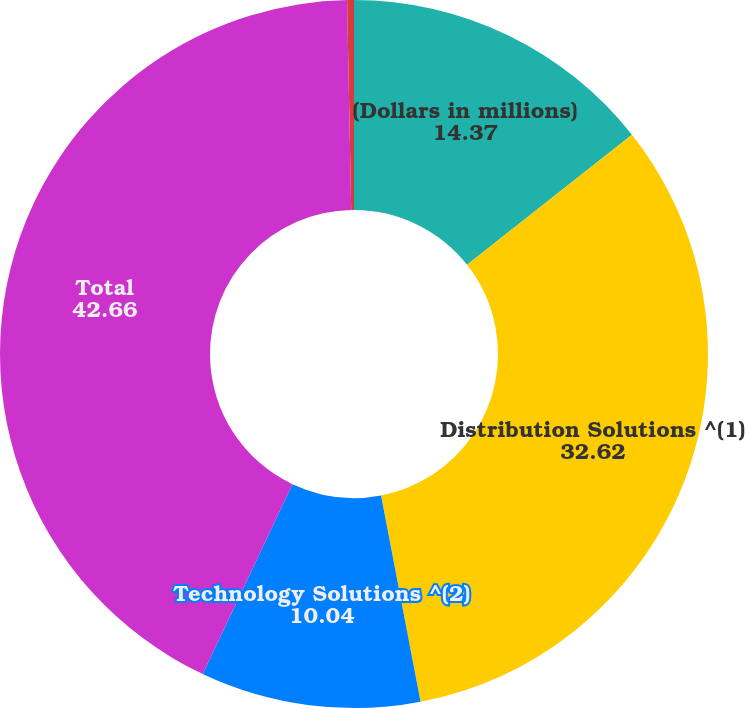Convert chart to OTSL. <chart><loc_0><loc_0><loc_500><loc_500><pie_chart><fcel>(Dollars in millions)<fcel>Distribution Solutions ^(1)<fcel>Technology Solutions ^(2)<fcel>Total<fcel>Technology Solutions<nl><fcel>14.37%<fcel>32.62%<fcel>10.04%<fcel>42.66%<fcel>0.31%<nl></chart> 